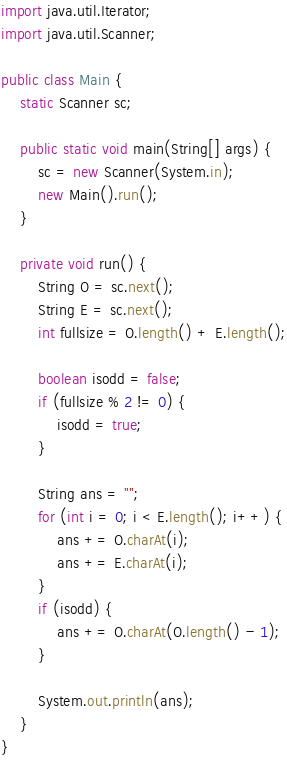Convert code to text. <code><loc_0><loc_0><loc_500><loc_500><_Java_>import java.util.Iterator;
import java.util.Scanner;

public class Main {
    static Scanner sc;

    public static void main(String[] args) {
        sc = new Scanner(System.in);
        new Main().run();
    }

    private void run() {
        String O = sc.next();
        String E = sc.next();
        int fullsize = O.length() + E.length();

        boolean isodd = false;
        if (fullsize % 2 != 0) {
            isodd = true;
        }

        String ans = "";
        for (int i = 0; i < E.length(); i++) {
            ans += O.charAt(i);
            ans += E.charAt(i);
        }
        if (isodd) {
            ans += O.charAt(O.length() - 1);
        }
        
        System.out.println(ans);
    }
}
</code> 